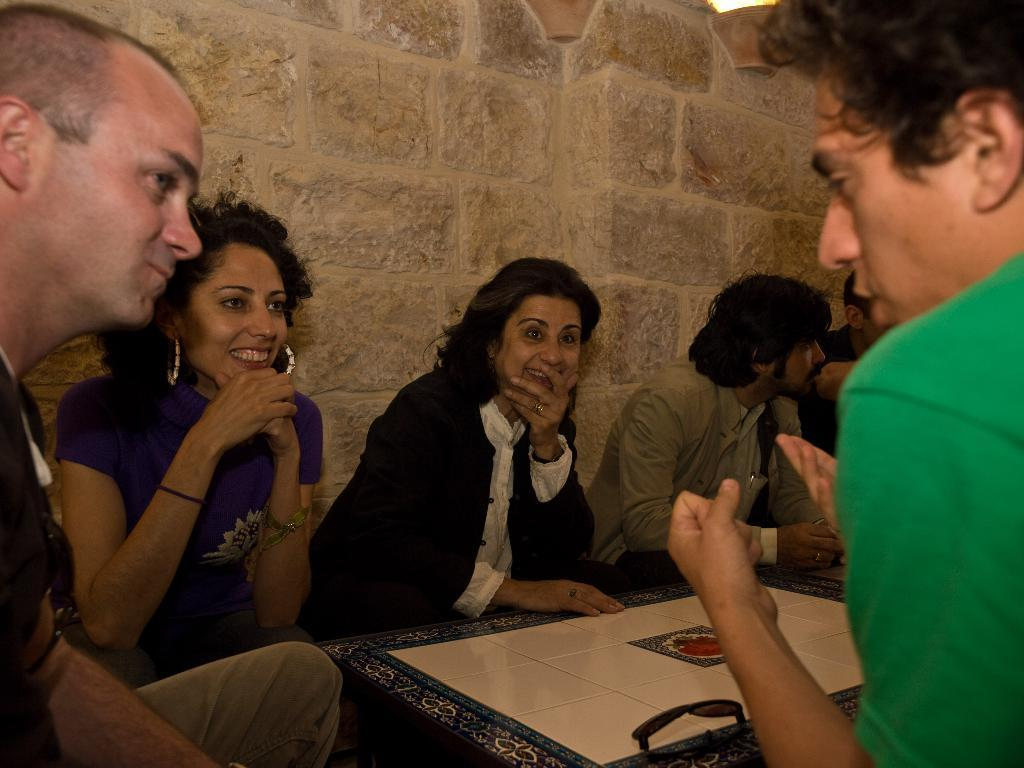What is the main object in the image? There is a carrom board in the image. Where is the carrom board located? The carrom board is on the right side of the image. What are the people in the image doing? It appears that the people are sitting around the carrom board and playing a game. What type of animal is sitting on the carrom board in the image? There are no animals present on the carrom board in the image. What is the purpose of the grip in the image? There is no mention of a grip in the image, so it cannot be determined what its purpose might be. 